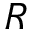Convert formula to latex. <formula><loc_0><loc_0><loc_500><loc_500>R</formula> 